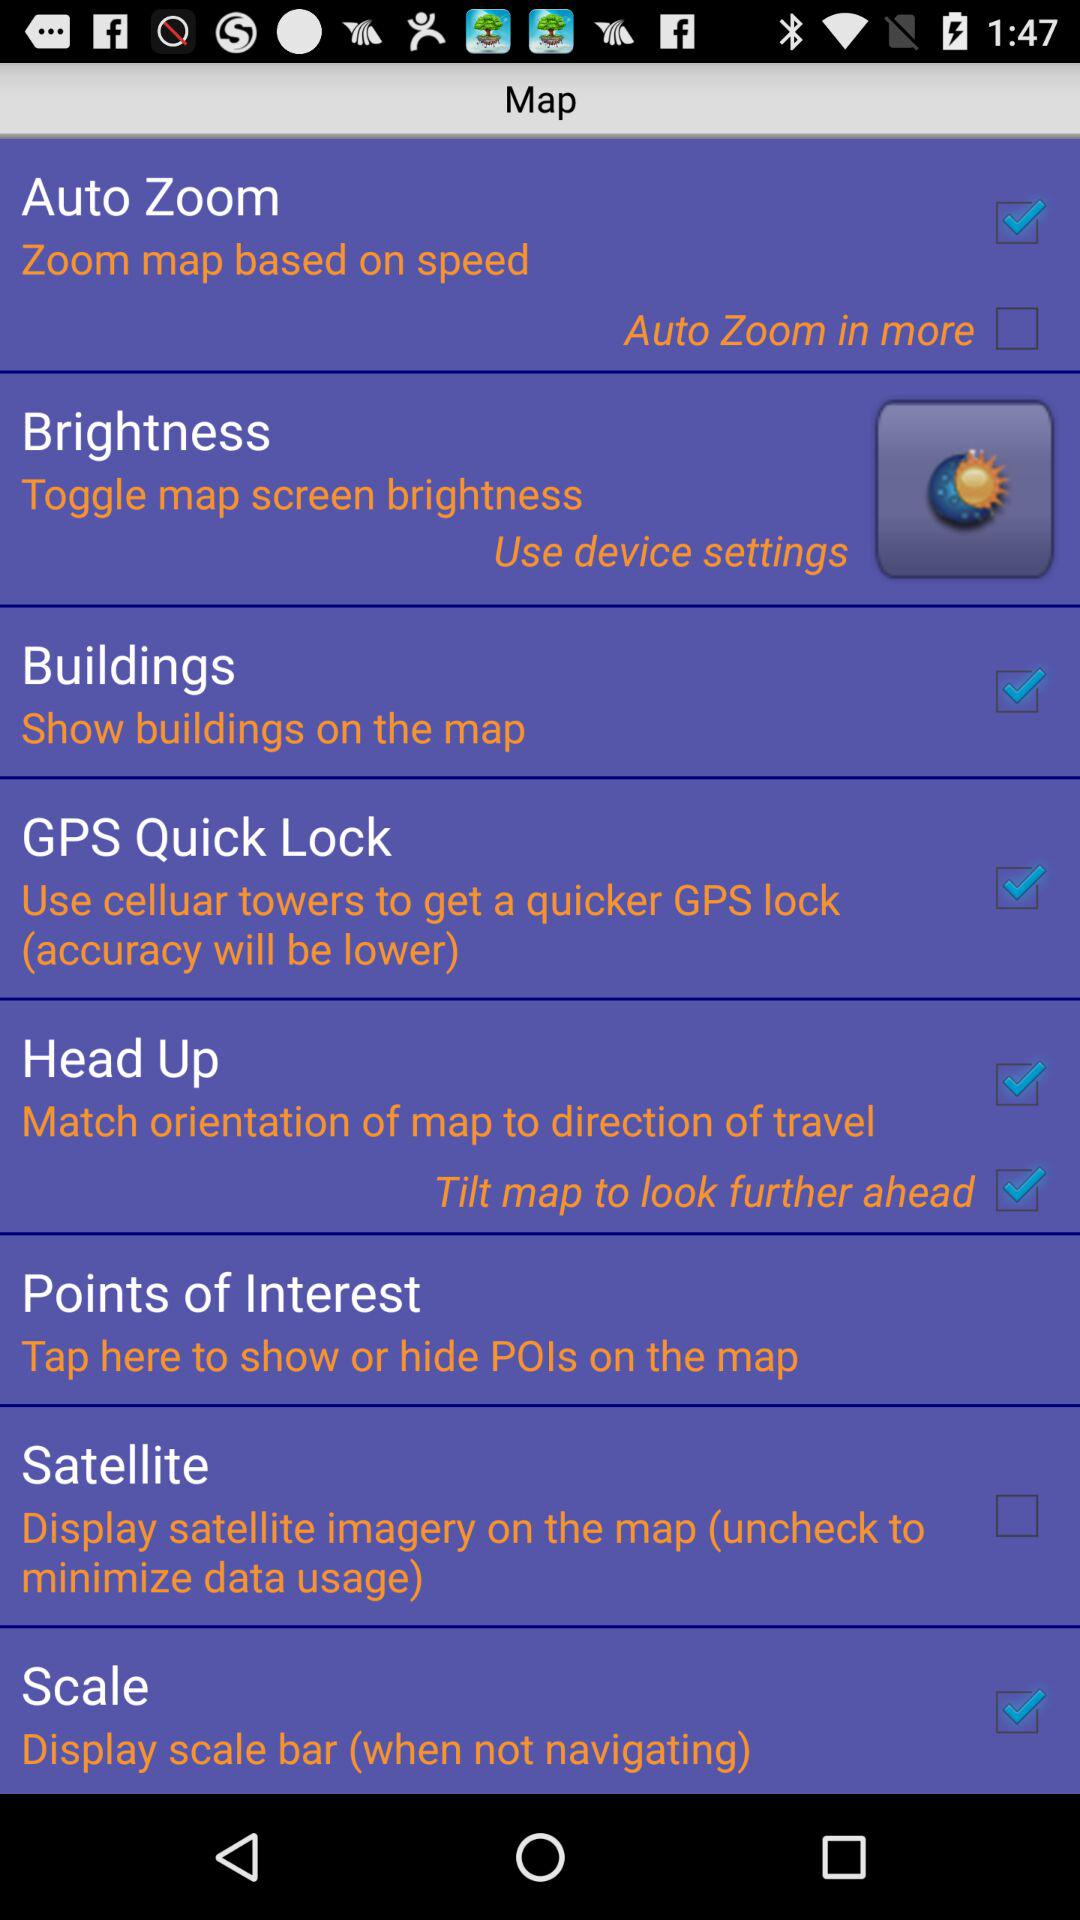What is the status of the "Tilt map to look further ahead" in head up? The status is on. 